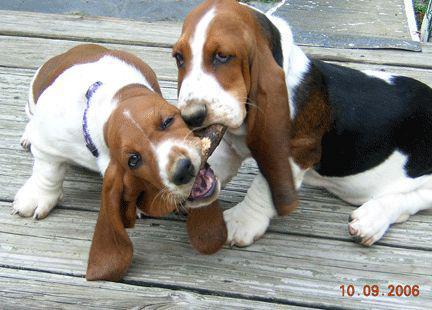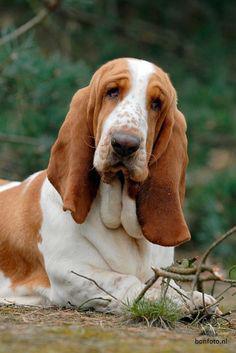The first image is the image on the left, the second image is the image on the right. Evaluate the accuracy of this statement regarding the images: "There is exactly two dogs in the left image.". Is it true? Answer yes or no. Yes. The first image is the image on the left, the second image is the image on the right. Analyze the images presented: Is the assertion "The right image shows one basset hound reclining on the ground, and the left image shows two hounds interacting." valid? Answer yes or no. Yes. 